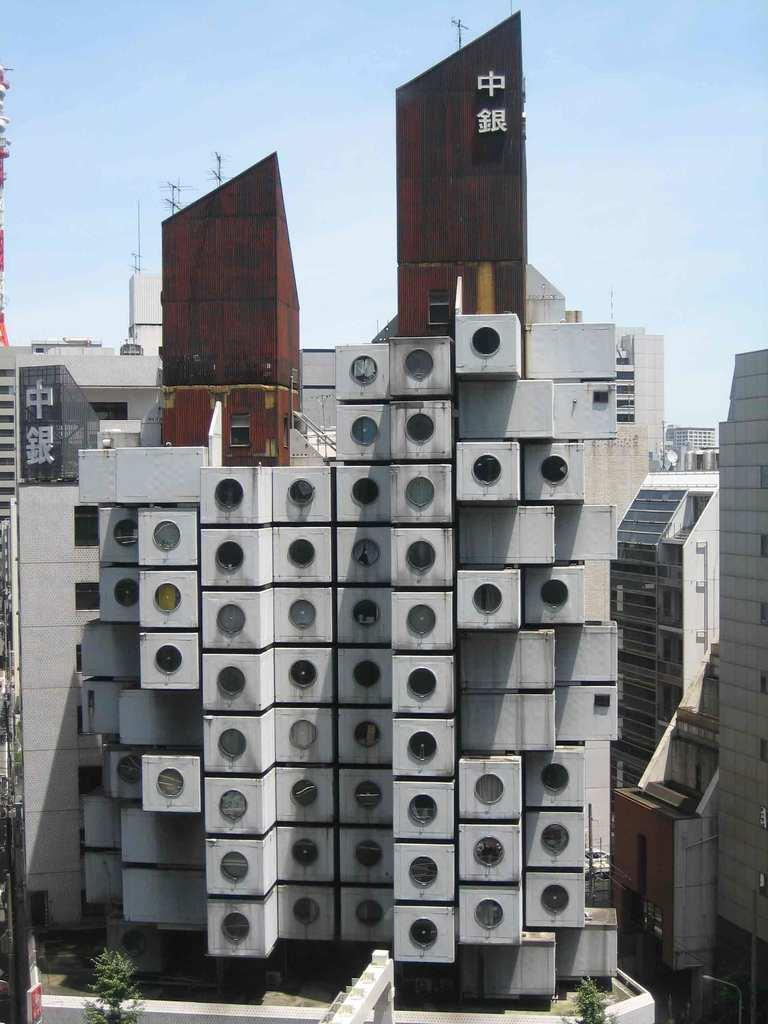<image>
Give a short and clear explanation of the subsequent image. A large abstract building that has Japanese kanji on it. 